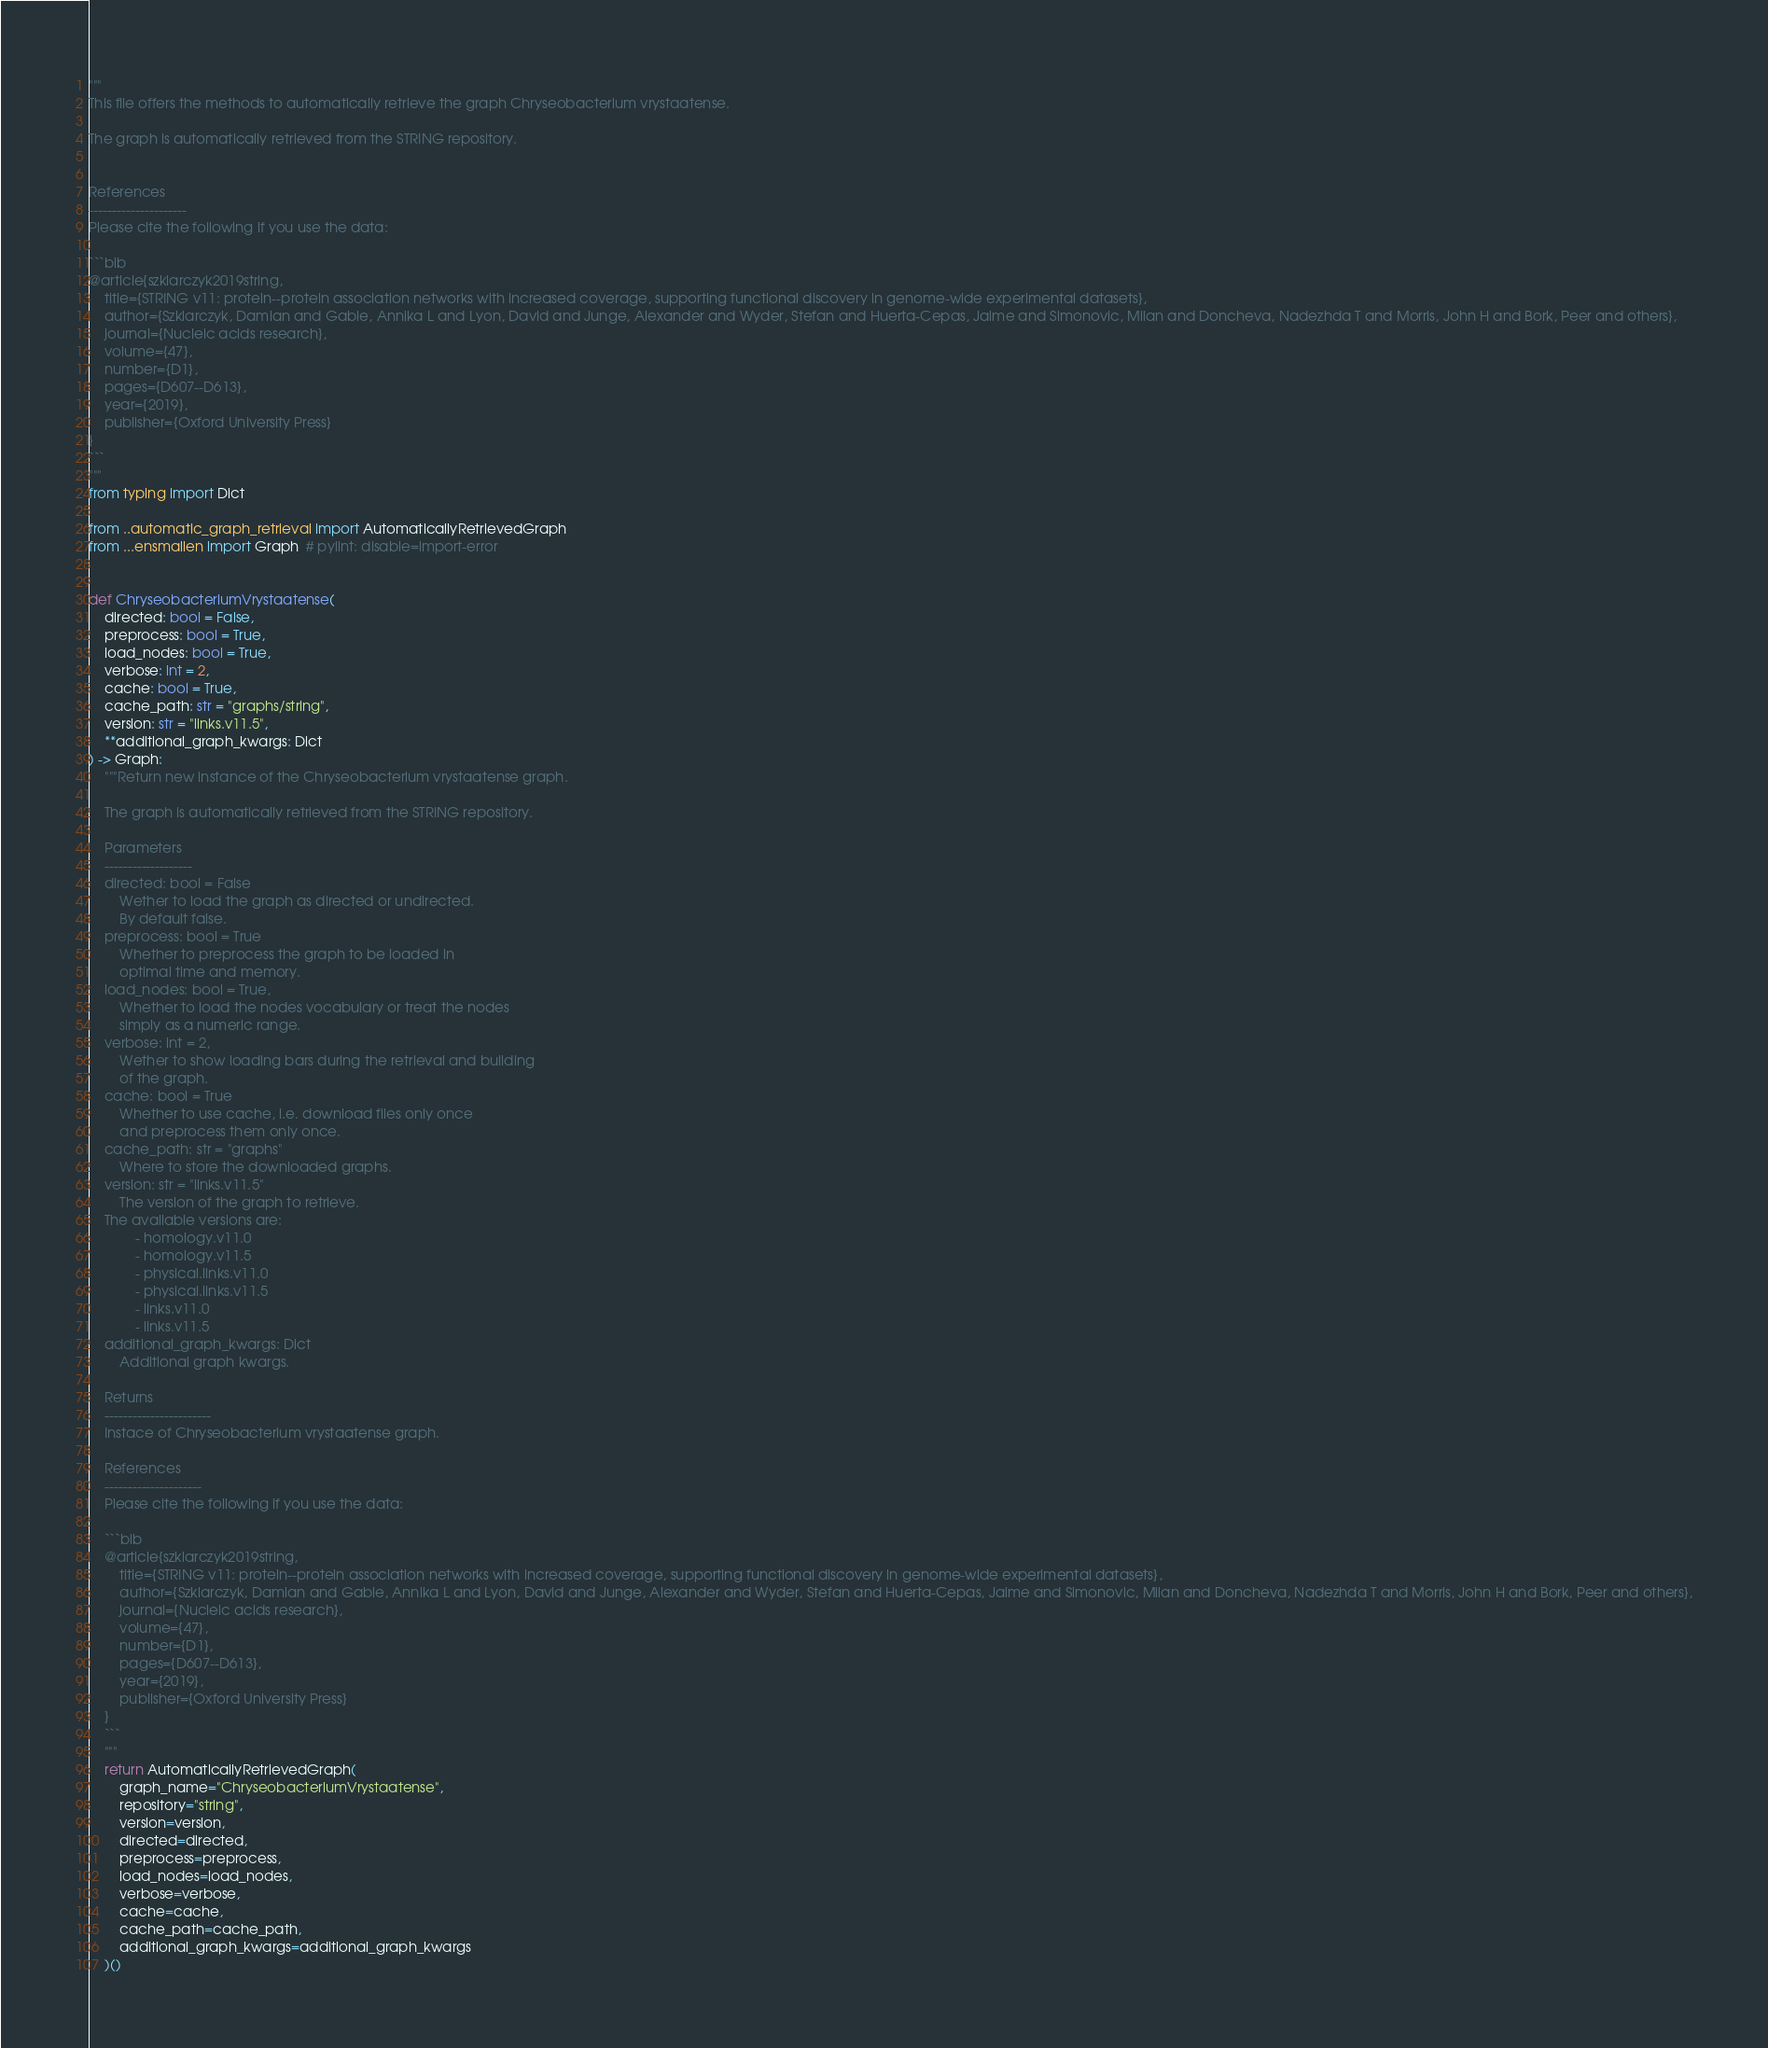Convert code to text. <code><loc_0><loc_0><loc_500><loc_500><_Python_>"""
This file offers the methods to automatically retrieve the graph Chryseobacterium vrystaatense.

The graph is automatically retrieved from the STRING repository. 


References
---------------------
Please cite the following if you use the data:

```bib
@article{szklarczyk2019string,
    title={STRING v11: protein--protein association networks with increased coverage, supporting functional discovery in genome-wide experimental datasets},
    author={Szklarczyk, Damian and Gable, Annika L and Lyon, David and Junge, Alexander and Wyder, Stefan and Huerta-Cepas, Jaime and Simonovic, Milan and Doncheva, Nadezhda T and Morris, John H and Bork, Peer and others},
    journal={Nucleic acids research},
    volume={47},
    number={D1},
    pages={D607--D613},
    year={2019},
    publisher={Oxford University Press}
}
```
"""
from typing import Dict

from ..automatic_graph_retrieval import AutomaticallyRetrievedGraph
from ...ensmallen import Graph  # pylint: disable=import-error


def ChryseobacteriumVrystaatense(
    directed: bool = False,
    preprocess: bool = True,
    load_nodes: bool = True,
    verbose: int = 2,
    cache: bool = True,
    cache_path: str = "graphs/string",
    version: str = "links.v11.5",
    **additional_graph_kwargs: Dict
) -> Graph:
    """Return new instance of the Chryseobacterium vrystaatense graph.

    The graph is automatically retrieved from the STRING repository.	

    Parameters
    -------------------
    directed: bool = False
        Wether to load the graph as directed or undirected.
        By default false.
    preprocess: bool = True
        Whether to preprocess the graph to be loaded in 
        optimal time and memory.
    load_nodes: bool = True,
        Whether to load the nodes vocabulary or treat the nodes
        simply as a numeric range.
    verbose: int = 2,
        Wether to show loading bars during the retrieval and building
        of the graph.
    cache: bool = True
        Whether to use cache, i.e. download files only once
        and preprocess them only once.
    cache_path: str = "graphs"
        Where to store the downloaded graphs.
    version: str = "links.v11.5"
        The version of the graph to retrieve.		
	The available versions are:
			- homology.v11.0
			- homology.v11.5
			- physical.links.v11.0
			- physical.links.v11.5
			- links.v11.0
			- links.v11.5
    additional_graph_kwargs: Dict
        Additional graph kwargs.

    Returns
    -----------------------
    Instace of Chryseobacterium vrystaatense graph.

	References
	---------------------
	Please cite the following if you use the data:
	
	```bib
	@article{szklarczyk2019string,
	    title={STRING v11: protein--protein association networks with increased coverage, supporting functional discovery in genome-wide experimental datasets},
	    author={Szklarczyk, Damian and Gable, Annika L and Lyon, David and Junge, Alexander and Wyder, Stefan and Huerta-Cepas, Jaime and Simonovic, Milan and Doncheva, Nadezhda T and Morris, John H and Bork, Peer and others},
	    journal={Nucleic acids research},
	    volume={47},
	    number={D1},
	    pages={D607--D613},
	    year={2019},
	    publisher={Oxford University Press}
	}
	```
    """
    return AutomaticallyRetrievedGraph(
        graph_name="ChryseobacteriumVrystaatense",
        repository="string",
        version=version,
        directed=directed,
        preprocess=preprocess,
        load_nodes=load_nodes,
        verbose=verbose,
        cache=cache,
        cache_path=cache_path,
        additional_graph_kwargs=additional_graph_kwargs
    )()
</code> 